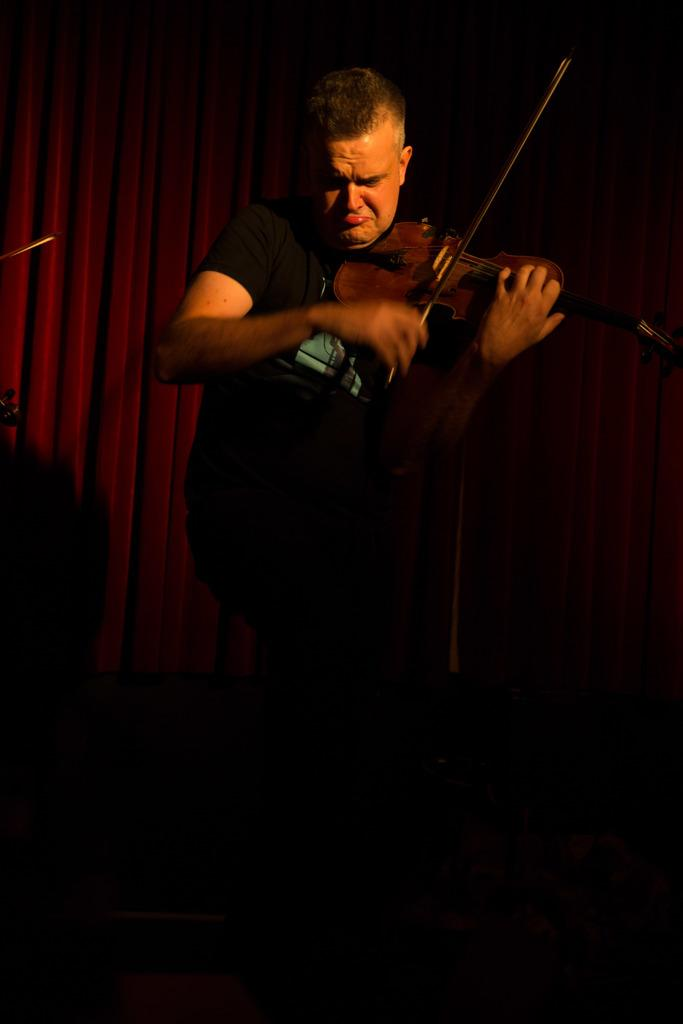What is the color of the curtain in the image? The curtain in the image is red. What can be seen in the background of the image? The background of the image is dark. What is the man in the image doing? The man is playing the violin and standing in front of a microphone. What is the man wearing in the image? The man is wearing a black t-shirt. What type of surprise is the man holding in the image? There is no surprise present in the image; the man is playing the violin and standing in front of a microphone. 